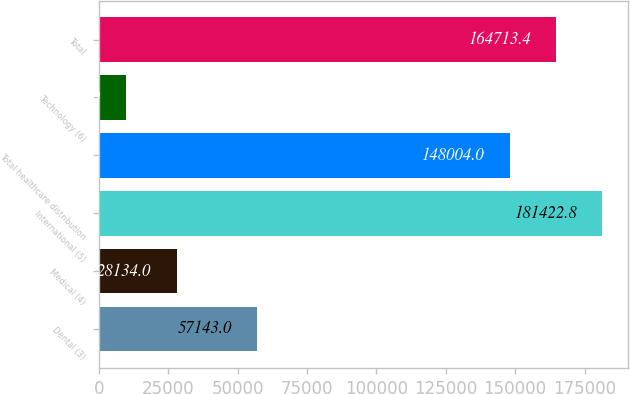Convert chart to OTSL. <chart><loc_0><loc_0><loc_500><loc_500><bar_chart><fcel>Dental (3)<fcel>Medical (4)<fcel>International (5)<fcel>Total healthcare distribution<fcel>Technology (6)<fcel>Total<nl><fcel>57143<fcel>28134<fcel>181423<fcel>148004<fcel>9919<fcel>164713<nl></chart> 